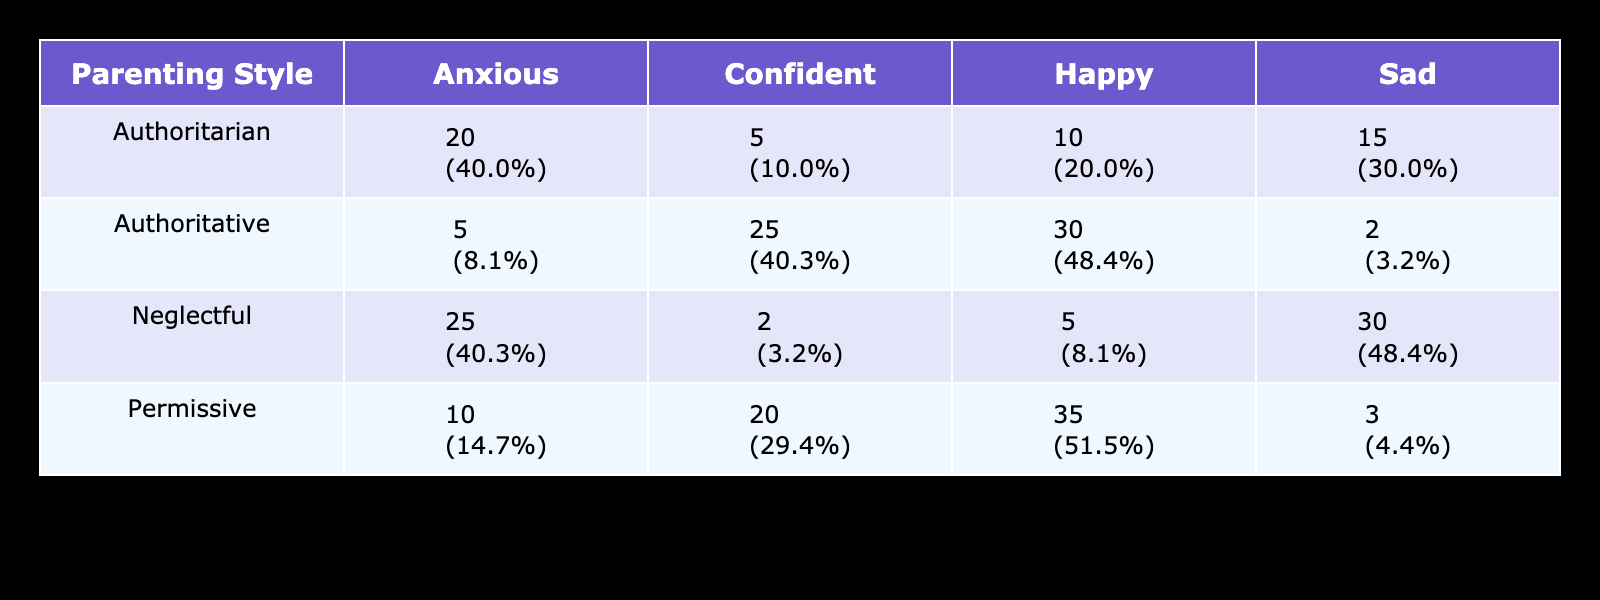What is the emotional response of children to the authoritative parenting style with the highest count? The table shows the counts of emotional responses for various parenting styles. Looking under the authoritative category, "Happy" has the highest count with 30.
Answer: Happy How many children feel happy under the permissive parenting style? According to the table, the count for "Happy" under the permissive parenting style is 35.
Answer: 35 What percentage of children respond with anxiety to authoritarian parenting? For authoritarian parenting, the count of anxious children is 20 and the total responses for authoritarian are 10 + 5 + 20 + 15 = 50. The percentage is (20/50) * 100 = 40%.
Answer: 40% Which parenting style leads to the highest overall count of confident emotional responses? The counts for confident responses are: authoritative (25), authoritarian (5), permissive (20), and neglectful (2). The highest is 25 under authoritative parenting.
Answer: Authoritative Is it true that neglectful parenting results in the lowest count of happy emotional responses? The count for happy emotional responses under neglectful parenting is 5, which is lower than other styles: authoritative (30), authoritarian (10), and permissive (35). Hence, this statement is true.
Answer: Yes What is the total count of children who feel sad across all parenting styles? The counts for sad responses are: authoritative (2), authoritarian (15), permissive (3), and neglectful (30). Adding them gives: 2 + 15 + 3 + 30 = 50.
Answer: 50 Which emotional response has the largest total count across all parenting styles? Summing the counts for each emotional response: happy (30 + 10 + 35 + 5 = 80), confident (25 + 5 + 20 + 2 = 52), anxious (5 + 20 + 10 + 25 = 60), sad (2 + 15 + 3 + 30 = 50). Happy has the largest count at 80.
Answer: Happy If you were to compare the "anxious" responses between authoritative and neglectful parenting styles, which is higher? The authoritative style has 5 anxious responses and neglectful has 25. Since 25 is greater than 5, neglectful leads to higher anxious responses.
Answer: Neglectful What is the average count of "confident" emotional responses across all parenting styles? The counts for confident responses are 25 (authoritative), 5 (authoritarian), 20 (permissive), and 2 (neglectful). Summing gives 25 + 5 + 20 + 2 = 52. With four styles, the average is 52/4 = 13.
Answer: 13 